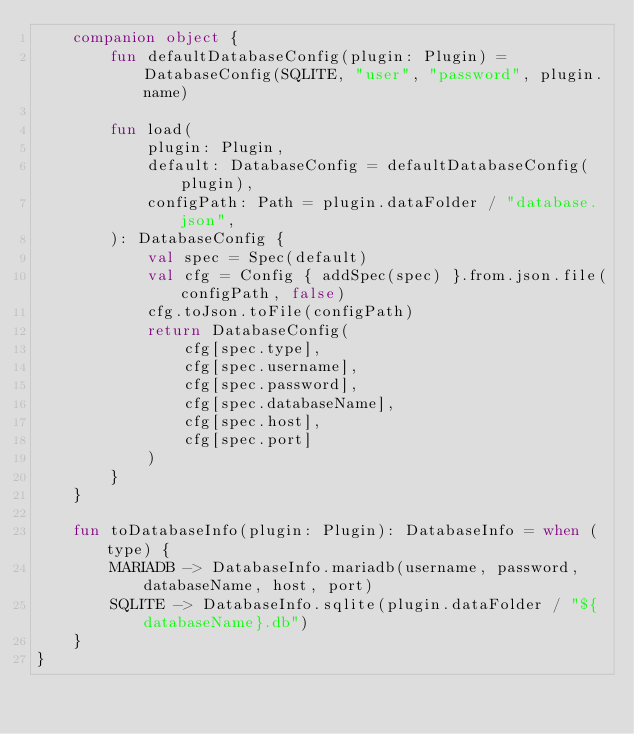<code> <loc_0><loc_0><loc_500><loc_500><_Kotlin_>    companion object {
        fun defaultDatabaseConfig(plugin: Plugin) = DatabaseConfig(SQLITE, "user", "password", plugin.name)

        fun load(
            plugin: Plugin,
            default: DatabaseConfig = defaultDatabaseConfig(plugin),
            configPath: Path = plugin.dataFolder / "database.json",
        ): DatabaseConfig {
            val spec = Spec(default)
            val cfg = Config { addSpec(spec) }.from.json.file(configPath, false)
            cfg.toJson.toFile(configPath)
            return DatabaseConfig(
                cfg[spec.type],
                cfg[spec.username],
                cfg[spec.password],
                cfg[spec.databaseName],
                cfg[spec.host],
                cfg[spec.port]
            )
        }
    }

    fun toDatabaseInfo(plugin: Plugin): DatabaseInfo = when (type) {
        MARIADB -> DatabaseInfo.mariadb(username, password, databaseName, host, port)
        SQLITE -> DatabaseInfo.sqlite(plugin.dataFolder / "${databaseName}.db")
    }
}
</code> 